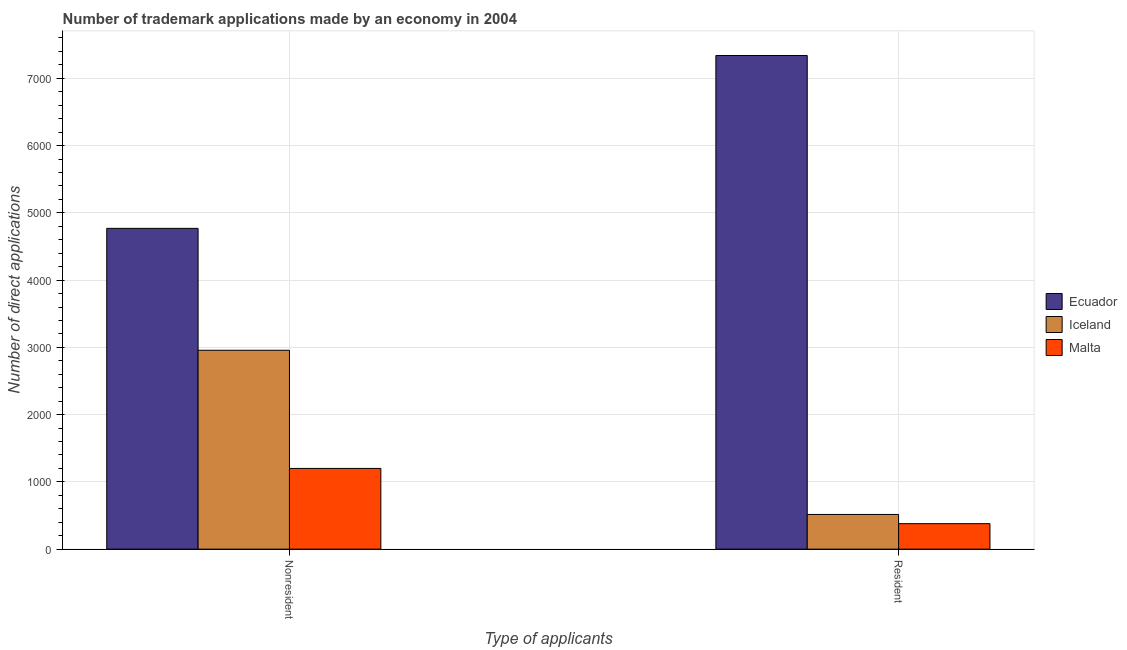Are the number of bars on each tick of the X-axis equal?
Keep it short and to the point. Yes. How many bars are there on the 2nd tick from the left?
Make the answer very short. 3. What is the label of the 1st group of bars from the left?
Your response must be concise. Nonresident. What is the number of trademark applications made by non residents in Iceland?
Provide a succinct answer. 2957. Across all countries, what is the maximum number of trademark applications made by non residents?
Your answer should be compact. 4769. Across all countries, what is the minimum number of trademark applications made by residents?
Offer a very short reply. 379. In which country was the number of trademark applications made by non residents maximum?
Your answer should be very brief. Ecuador. In which country was the number of trademark applications made by non residents minimum?
Offer a terse response. Malta. What is the total number of trademark applications made by residents in the graph?
Ensure brevity in your answer.  8234. What is the difference between the number of trademark applications made by non residents in Ecuador and that in Malta?
Provide a succinct answer. 3569. What is the difference between the number of trademark applications made by non residents in Ecuador and the number of trademark applications made by residents in Iceland?
Your answer should be very brief. 4253. What is the average number of trademark applications made by residents per country?
Your answer should be very brief. 2744.67. What is the difference between the number of trademark applications made by residents and number of trademark applications made by non residents in Malta?
Provide a short and direct response. -821. In how many countries, is the number of trademark applications made by residents greater than 1800 ?
Make the answer very short. 1. What is the ratio of the number of trademark applications made by residents in Ecuador to that in Malta?
Keep it short and to the point. 19.36. Is the number of trademark applications made by residents in Malta less than that in Ecuador?
Give a very brief answer. Yes. In how many countries, is the number of trademark applications made by residents greater than the average number of trademark applications made by residents taken over all countries?
Offer a terse response. 1. What does the 1st bar from the left in Nonresident represents?
Ensure brevity in your answer.  Ecuador. What does the 1st bar from the right in Resident represents?
Your response must be concise. Malta. Are all the bars in the graph horizontal?
Make the answer very short. No. How many countries are there in the graph?
Make the answer very short. 3. Are the values on the major ticks of Y-axis written in scientific E-notation?
Offer a very short reply. No. Does the graph contain grids?
Offer a very short reply. Yes. Where does the legend appear in the graph?
Your answer should be compact. Center right. How are the legend labels stacked?
Ensure brevity in your answer.  Vertical. What is the title of the graph?
Offer a very short reply. Number of trademark applications made by an economy in 2004. Does "Dominica" appear as one of the legend labels in the graph?
Provide a short and direct response. No. What is the label or title of the X-axis?
Keep it short and to the point. Type of applicants. What is the label or title of the Y-axis?
Your response must be concise. Number of direct applications. What is the Number of direct applications in Ecuador in Nonresident?
Make the answer very short. 4769. What is the Number of direct applications of Iceland in Nonresident?
Offer a very short reply. 2957. What is the Number of direct applications of Malta in Nonresident?
Provide a short and direct response. 1200. What is the Number of direct applications in Ecuador in Resident?
Make the answer very short. 7339. What is the Number of direct applications of Iceland in Resident?
Your answer should be very brief. 516. What is the Number of direct applications of Malta in Resident?
Give a very brief answer. 379. Across all Type of applicants, what is the maximum Number of direct applications of Ecuador?
Give a very brief answer. 7339. Across all Type of applicants, what is the maximum Number of direct applications of Iceland?
Make the answer very short. 2957. Across all Type of applicants, what is the maximum Number of direct applications of Malta?
Provide a short and direct response. 1200. Across all Type of applicants, what is the minimum Number of direct applications of Ecuador?
Give a very brief answer. 4769. Across all Type of applicants, what is the minimum Number of direct applications in Iceland?
Offer a terse response. 516. Across all Type of applicants, what is the minimum Number of direct applications in Malta?
Make the answer very short. 379. What is the total Number of direct applications of Ecuador in the graph?
Your answer should be compact. 1.21e+04. What is the total Number of direct applications of Iceland in the graph?
Provide a succinct answer. 3473. What is the total Number of direct applications in Malta in the graph?
Provide a succinct answer. 1579. What is the difference between the Number of direct applications in Ecuador in Nonresident and that in Resident?
Make the answer very short. -2570. What is the difference between the Number of direct applications of Iceland in Nonresident and that in Resident?
Give a very brief answer. 2441. What is the difference between the Number of direct applications in Malta in Nonresident and that in Resident?
Your answer should be compact. 821. What is the difference between the Number of direct applications in Ecuador in Nonresident and the Number of direct applications in Iceland in Resident?
Your answer should be very brief. 4253. What is the difference between the Number of direct applications in Ecuador in Nonresident and the Number of direct applications in Malta in Resident?
Provide a succinct answer. 4390. What is the difference between the Number of direct applications in Iceland in Nonresident and the Number of direct applications in Malta in Resident?
Offer a terse response. 2578. What is the average Number of direct applications in Ecuador per Type of applicants?
Make the answer very short. 6054. What is the average Number of direct applications of Iceland per Type of applicants?
Give a very brief answer. 1736.5. What is the average Number of direct applications of Malta per Type of applicants?
Provide a succinct answer. 789.5. What is the difference between the Number of direct applications in Ecuador and Number of direct applications in Iceland in Nonresident?
Your response must be concise. 1812. What is the difference between the Number of direct applications of Ecuador and Number of direct applications of Malta in Nonresident?
Give a very brief answer. 3569. What is the difference between the Number of direct applications of Iceland and Number of direct applications of Malta in Nonresident?
Make the answer very short. 1757. What is the difference between the Number of direct applications in Ecuador and Number of direct applications in Iceland in Resident?
Keep it short and to the point. 6823. What is the difference between the Number of direct applications of Ecuador and Number of direct applications of Malta in Resident?
Give a very brief answer. 6960. What is the difference between the Number of direct applications of Iceland and Number of direct applications of Malta in Resident?
Make the answer very short. 137. What is the ratio of the Number of direct applications of Ecuador in Nonresident to that in Resident?
Your response must be concise. 0.65. What is the ratio of the Number of direct applications of Iceland in Nonresident to that in Resident?
Offer a terse response. 5.73. What is the ratio of the Number of direct applications of Malta in Nonresident to that in Resident?
Give a very brief answer. 3.17. What is the difference between the highest and the second highest Number of direct applications in Ecuador?
Your answer should be very brief. 2570. What is the difference between the highest and the second highest Number of direct applications in Iceland?
Make the answer very short. 2441. What is the difference between the highest and the second highest Number of direct applications of Malta?
Your answer should be very brief. 821. What is the difference between the highest and the lowest Number of direct applications of Ecuador?
Your answer should be very brief. 2570. What is the difference between the highest and the lowest Number of direct applications in Iceland?
Offer a terse response. 2441. What is the difference between the highest and the lowest Number of direct applications in Malta?
Your answer should be very brief. 821. 